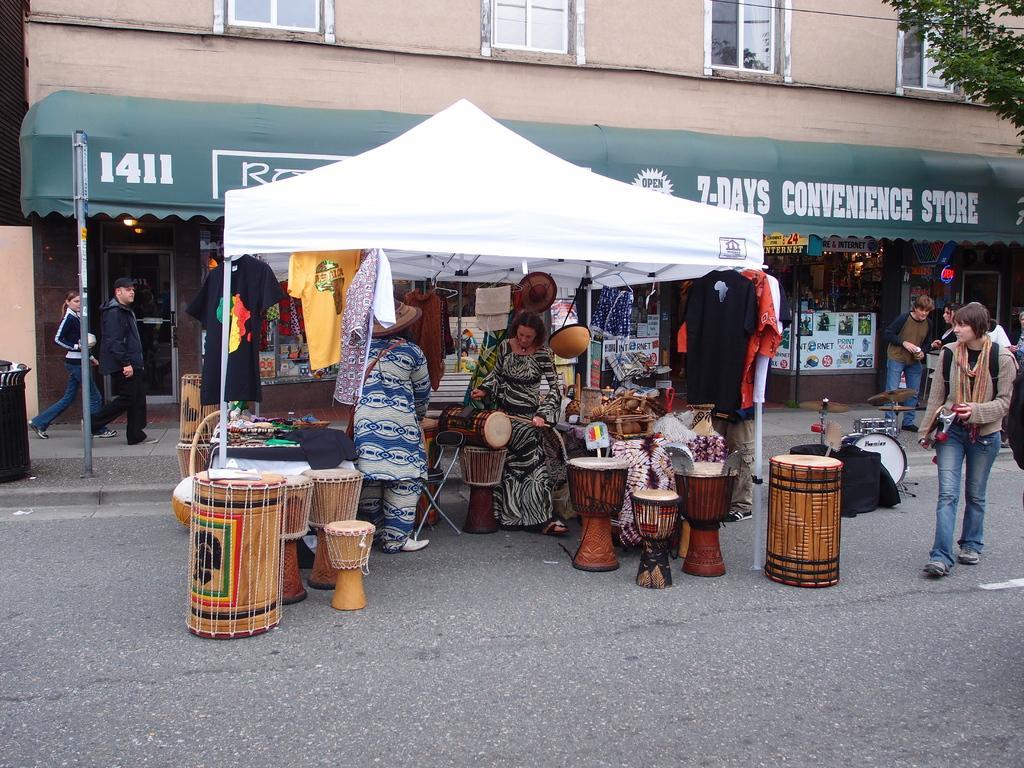Can you describe this image briefly? In the image we can see there are people who are standing on road and at the back there is a building and a white colour tent. 